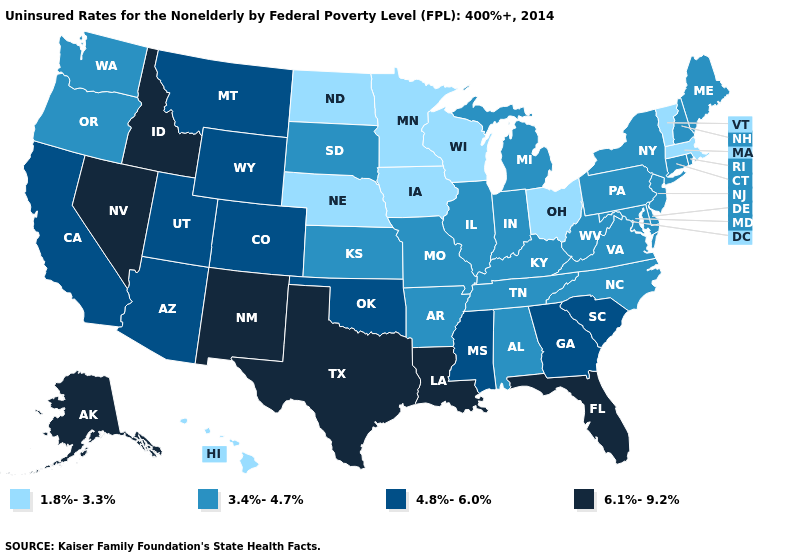Name the states that have a value in the range 4.8%-6.0%?
Short answer required. Arizona, California, Colorado, Georgia, Mississippi, Montana, Oklahoma, South Carolina, Utah, Wyoming. Is the legend a continuous bar?
Keep it brief. No. Among the states that border Florida , which have the highest value?
Keep it brief. Georgia. What is the value of Georgia?
Answer briefly. 4.8%-6.0%. Name the states that have a value in the range 3.4%-4.7%?
Quick response, please. Alabama, Arkansas, Connecticut, Delaware, Illinois, Indiana, Kansas, Kentucky, Maine, Maryland, Michigan, Missouri, New Hampshire, New Jersey, New York, North Carolina, Oregon, Pennsylvania, Rhode Island, South Dakota, Tennessee, Virginia, Washington, West Virginia. Does the first symbol in the legend represent the smallest category?
Keep it brief. Yes. Which states have the highest value in the USA?
Answer briefly. Alaska, Florida, Idaho, Louisiana, Nevada, New Mexico, Texas. Name the states that have a value in the range 6.1%-9.2%?
Keep it brief. Alaska, Florida, Idaho, Louisiana, Nevada, New Mexico, Texas. What is the value of New York?
Be succinct. 3.4%-4.7%. How many symbols are there in the legend?
Give a very brief answer. 4. Does Alaska have the highest value in the USA?
Write a very short answer. Yes. Which states have the highest value in the USA?
Quick response, please. Alaska, Florida, Idaho, Louisiana, Nevada, New Mexico, Texas. Which states have the lowest value in the USA?
Quick response, please. Hawaii, Iowa, Massachusetts, Minnesota, Nebraska, North Dakota, Ohio, Vermont, Wisconsin. Does Massachusetts have the highest value in the Northeast?
Keep it brief. No. Does the map have missing data?
Keep it brief. No. 